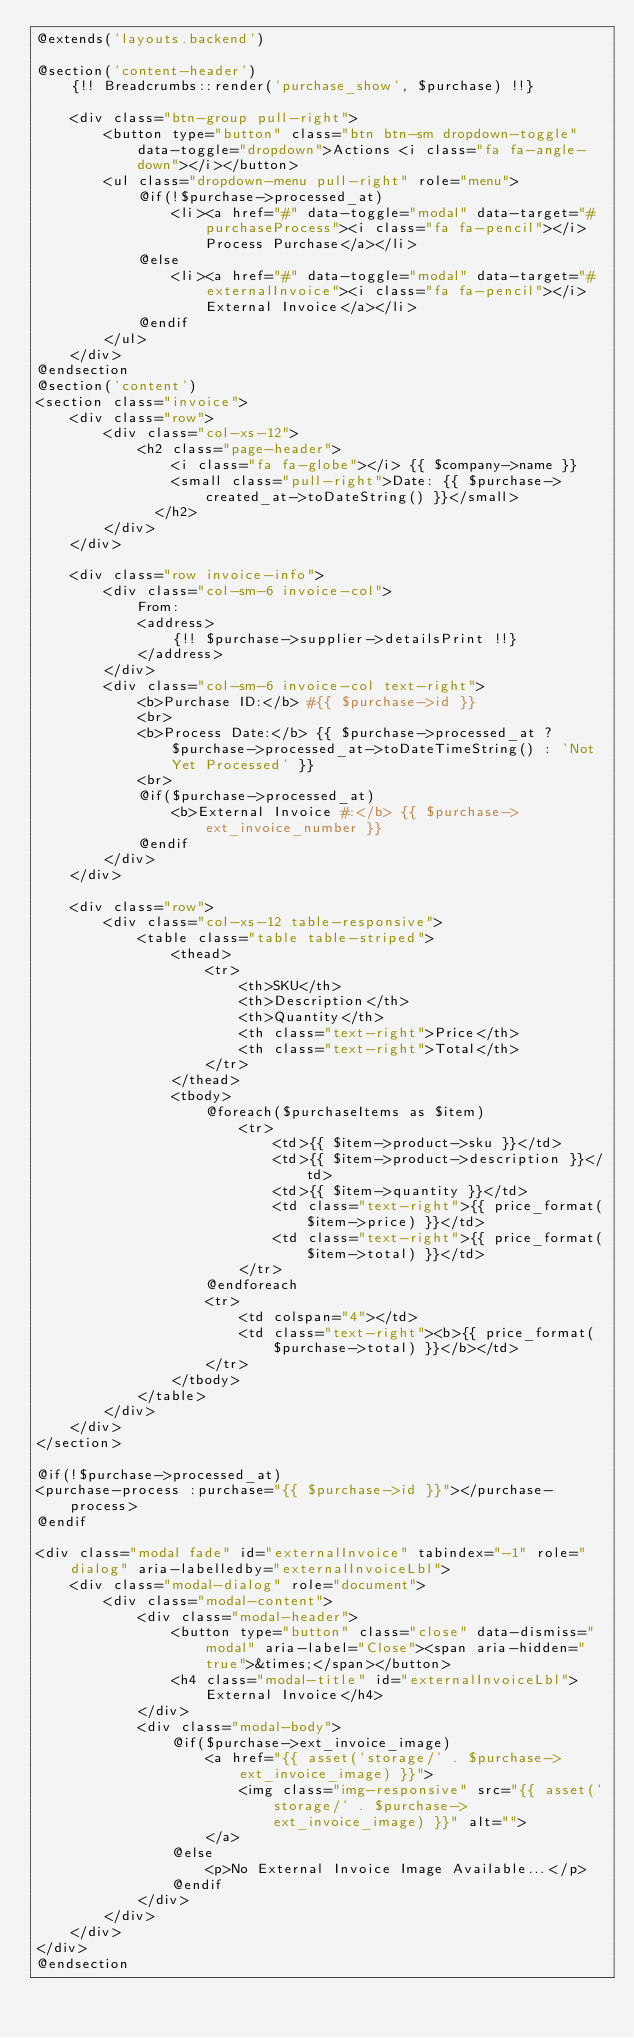Convert code to text. <code><loc_0><loc_0><loc_500><loc_500><_PHP_>@extends('layouts.backend')

@section('content-header')
    {!! Breadcrumbs::render('purchase_show', $purchase) !!}

    <div class="btn-group pull-right">
        <button type="button" class="btn btn-sm dropdown-toggle" data-toggle="dropdown">Actions <i class="fa fa-angle-down"></i></button>
        <ul class="dropdown-menu pull-right" role="menu">
            @if(!$purchase->processed_at)
                <li><a href="#" data-toggle="modal" data-target="#purchaseProcess"><i class="fa fa-pencil"></i> Process Purchase</a></li>
            @else
                <li><a href="#" data-toggle="modal" data-target="#externalInvoice"><i class="fa fa-pencil"></i> External Invoice</a></li>
            @endif
        </ul>
    </div>
@endsection
@section('content')
<section class="invoice">
    <div class="row">
        <div class="col-xs-12">
            <h2 class="page-header">
                <i class="fa fa-globe"></i> {{ $company->name }}
                <small class="pull-right">Date: {{ $purchase->created_at->toDateString() }}</small>
              </h2>
        </div>
    </div>

    <div class="row invoice-info">
        <div class="col-sm-6 invoice-col">
            From:
            <address>
                {!! $purchase->supplier->detailsPrint !!}
            </address>
        </div>
        <div class="col-sm-6 invoice-col text-right">
            <b>Purchase ID:</b> #{{ $purchase->id }}
            <br>
            <b>Process Date:</b> {{ $purchase->processed_at ?  $purchase->processed_at->toDateTimeString() : 'Not Yet Processed' }}
            <br>
            @if($purchase->processed_at)
                <b>External Invoice #:</b> {{ $purchase->ext_invoice_number }}
            @endif
        </div>
    </div>

    <div class="row">
        <div class="col-xs-12 table-responsive">
            <table class="table table-striped">
                <thead>
                    <tr>
                        <th>SKU</th>
                        <th>Description</th>
                        <th>Quantity</th>
                        <th class="text-right">Price</th>
                        <th class="text-right">Total</th>
                    </tr>
                </thead>
                <tbody>
                    @foreach($purchaseItems as $item)
                        <tr>
                            <td>{{ $item->product->sku }}</td>
                            <td>{{ $item->product->description }}</td>
                            <td>{{ $item->quantity }}</td>
                            <td class="text-right">{{ price_format($item->price) }}</td>
                            <td class="text-right">{{ price_format($item->total) }}</td>
                        </tr>
                    @endforeach
                    <tr>
                        <td colspan="4"></td>
                        <td class="text-right"><b>{{ price_format($purchase->total) }}</b></td>
                    </tr>
                </tbody>
            </table>
        </div>
    </div>
</section>

@if(!$purchase->processed_at)
<purchase-process :purchase="{{ $purchase->id }}"></purchase-process>
@endif

<div class="modal fade" id="externalInvoice" tabindex="-1" role="dialog" aria-labelledby="externalInvoiceLbl">
    <div class="modal-dialog" role="document">
        <div class="modal-content">
            <div class="modal-header">
                <button type="button" class="close" data-dismiss="modal" aria-label="Close"><span aria-hidden="true">&times;</span></button>
                <h4 class="modal-title" id="externalInvoiceLbl">External Invoice</h4>
            </div>
            <div class="modal-body">
                @if($purchase->ext_invoice_image)
                    <a href="{{ asset('storage/' . $purchase->ext_invoice_image) }}">
                        <img class="img-responsive" src="{{ asset('storage/' . $purchase->ext_invoice_image) }}" alt="">
                    </a>
                @else
                    <p>No External Invoice Image Available...</p>
                @endif
            </div>
        </div>
    </div>
</div>
@endsection
</code> 